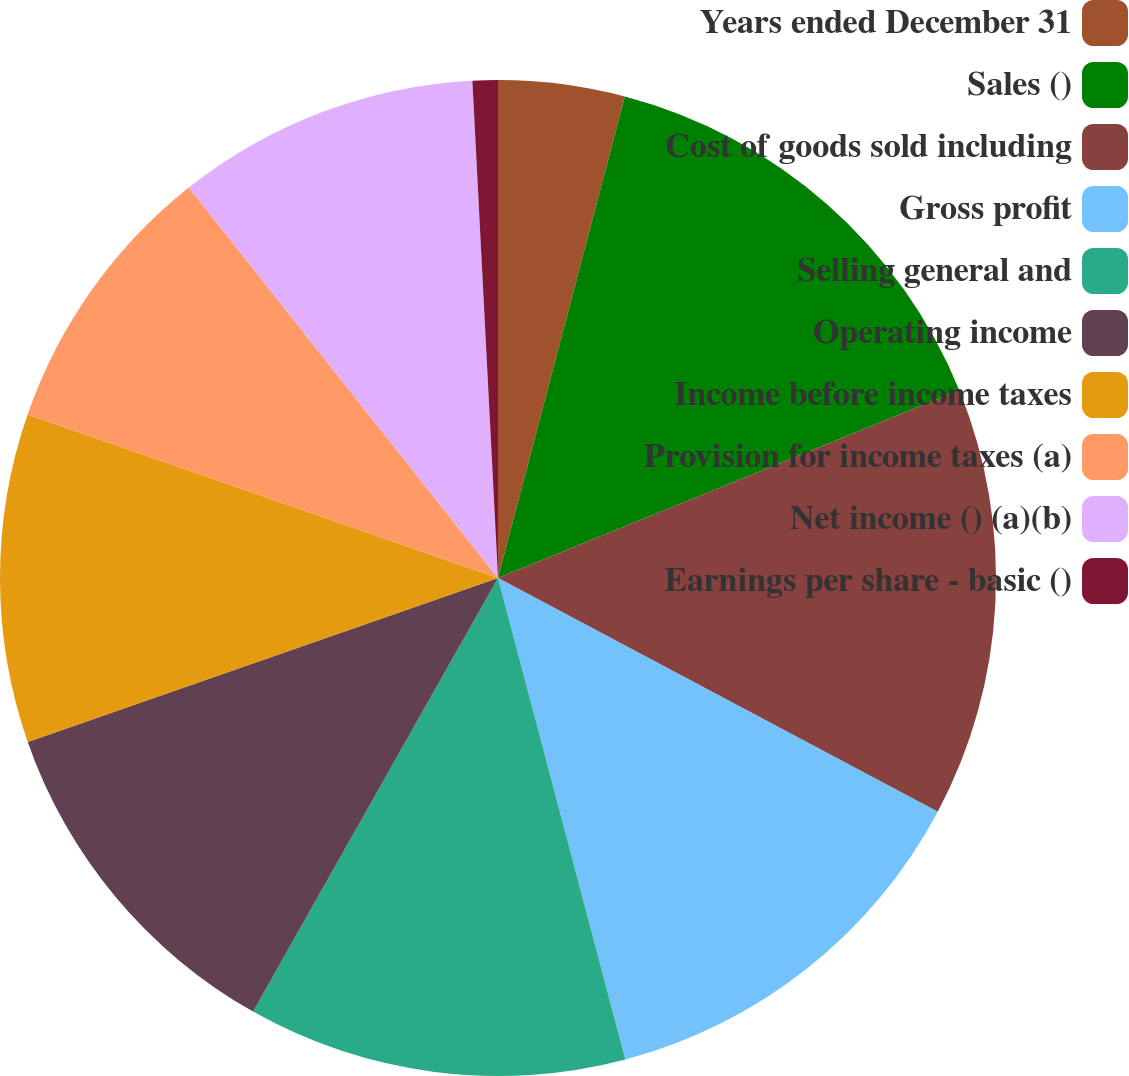<chart> <loc_0><loc_0><loc_500><loc_500><pie_chart><fcel>Years ended December 31<fcel>Sales ()<fcel>Cost of goods sold including<fcel>Gross profit<fcel>Selling general and<fcel>Operating income<fcel>Income before income taxes<fcel>Provision for income taxes (a)<fcel>Net income () (a)(b)<fcel>Earnings per share - basic ()<nl><fcel>4.1%<fcel>14.75%<fcel>13.93%<fcel>13.11%<fcel>12.3%<fcel>11.48%<fcel>10.66%<fcel>9.02%<fcel>9.84%<fcel>0.82%<nl></chart> 